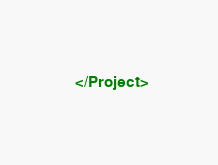Convert code to text. <code><loc_0><loc_0><loc_500><loc_500><_XML_>
</Project>
</code> 